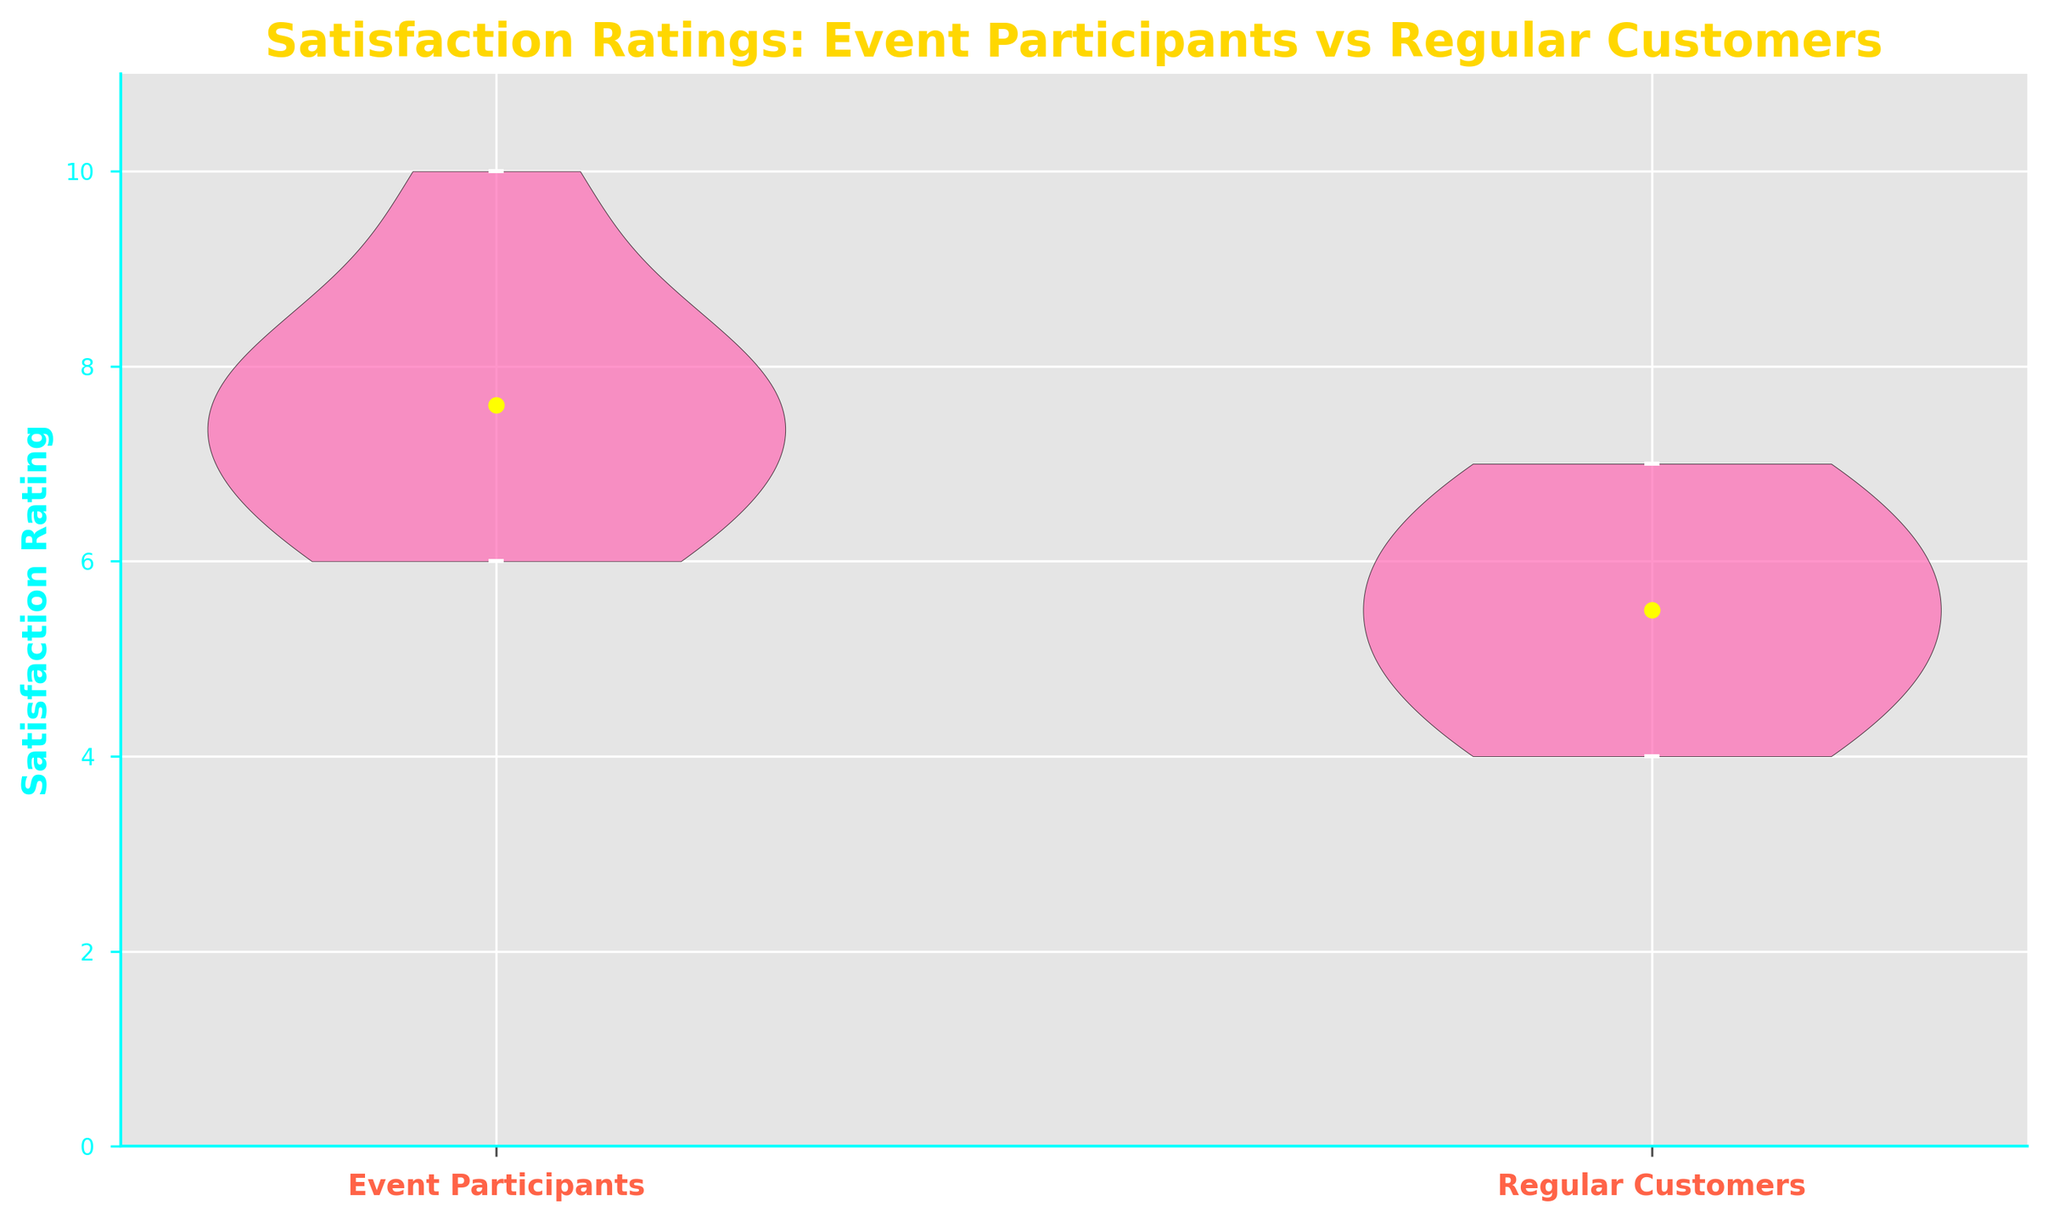What's the title of the chart? The title of the chart is displayed at the top of the figure. It reads "Satisfaction Ratings: Event Participants vs Regular Customers".
Answer: Satisfaction Ratings: Event Participants vs Regular Customers What are the two groups compared in the chart? The groups compared in the chart are labeled on the x-axis as 'Event Participants' and 'Regular Customers'.
Answer: Event Participants and Regular Customers What is the range of satisfaction ratings for event participants? The chart shows that the range of satisfaction ratings for event participants spans from the minimum value (6) to the maximum value (10), as indicated by the scatter markers.
Answer: 6 to 10 Which group has a higher mean satisfaction rating? The mean satisfaction ratings are shown with yellow dots on the violin plot. The yellow dot for event participants is higher up on the y-axis compared to regular customers.
Answer: Event Participants What is the lowest satisfaction rating among regular customers? The lowest satisfaction rating among regular customers can be identified by the lowest scatter marker on the y-axis within the 'Regular Customers' violin plot, which is 4.
Answer: 4 Compare the variability of satisfaction ratings between the two groups. The variability of satisfaction ratings can be assessed by the width and spread of the violin plots. Event participants show a wider plot, suggesting more variability, while regular customers have a narrower plot, indicating less variability.
Answer: Event Participants have more variability What is the highest rating received by any regular customer? The highest satisfaction rating among regular customers can be identified by the highest scatter marker on the y-axis within the 'Regular Customers' violin plot, which is 7.
Answer: 7 Are the satisfaction ratings of event participants generally higher than those of regular customers? Comparing the position and spread of the violin plots, event participants' ratings are generally higher (ranging from 6 to 10) than regular customers' ratings (ranging from 4 to 7), indicating overall higher satisfaction.
Answer: Yes What is the difference between the highest rating of event participants and the lowest rating of regular customers? The highest rating among event participants is 10, and the lowest rating among regular customers is 4. The difference is calculated as 10 - 4 = 6.
Answer: 6 Based on the chart, what inference can you make about customer satisfaction for events versus regular store visits? The higher and more variable ratings for event participants suggest that community events are more positively received, whereas regular store visits have lower and less varied satisfaction ratings.
Answer: Events are more positively received 